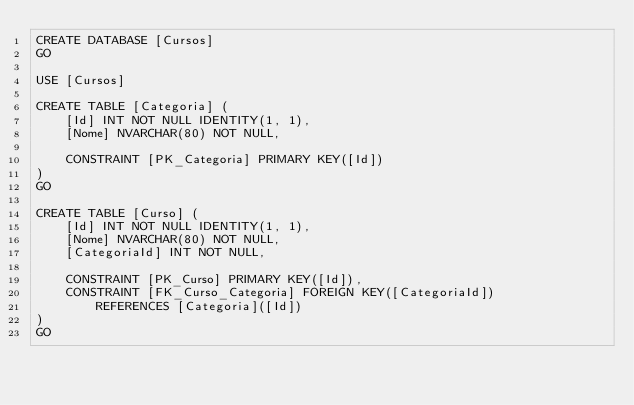<code> <loc_0><loc_0><loc_500><loc_500><_SQL_>CREATE DATABASE [Cursos]
GO

USE [Cursos]

CREATE TABLE [Categoria] (
    [Id] INT NOT NULL IDENTITY(1, 1), 
    [Nome] NVARCHAR(80) NOT NULL,

    CONSTRAINT [PK_Categoria] PRIMARY KEY([Id])
)
GO

CREATE TABLE [Curso] (
    [Id] INT NOT NULL IDENTITY(1, 1), 
    [Nome] NVARCHAR(80) NOT NULL,
    [CategoriaId] INT NOT NULL,

    CONSTRAINT [PK_Curso] PRIMARY KEY([Id]),
    CONSTRAINT [FK_Curso_Categoria] FOREIGN KEY([CategoriaId])
        REFERENCES [Categoria]([Id])
)
GO</code> 